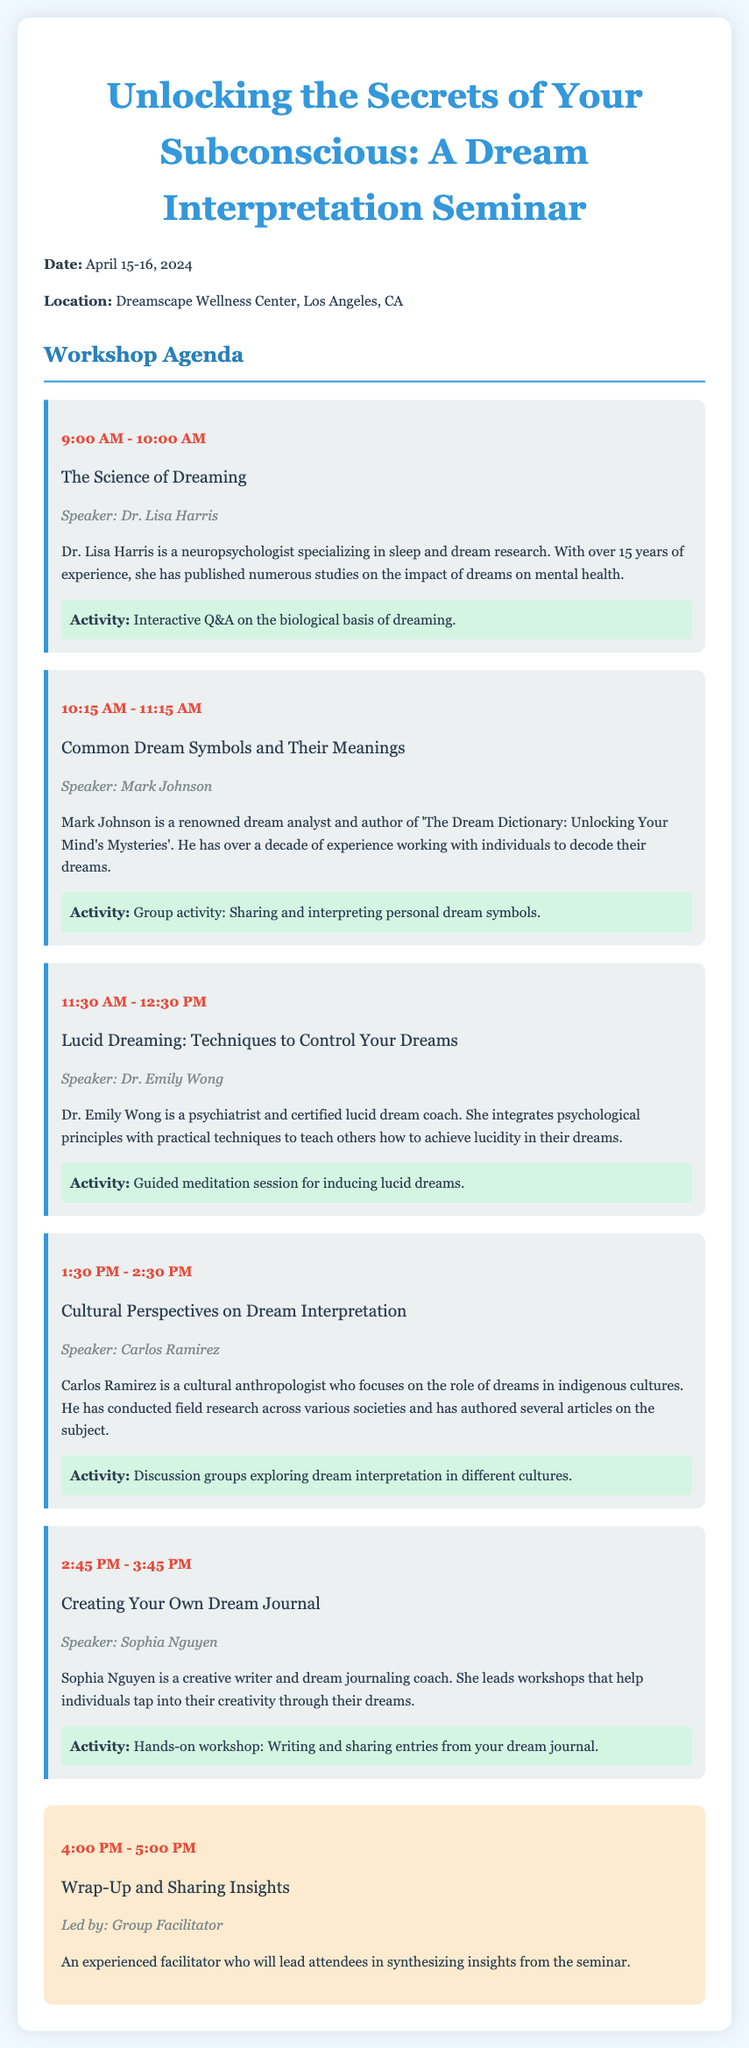what is the date of the seminar? The date of the seminar is specified at the beginning of the document.
Answer: April 15-16, 2024 what is the location of the seminar? The location of the seminar is mentioned in the introductory section of the document.
Answer: Dreamscape Wellness Center, Los Angeles, CA who is the speaker for the session on lucid dreaming? The speaker for the session on lucid dreaming can be found within the session details.
Answer: Dr. Emily Wong what is the title of the session at 1:30 PM? The title of the session at 1:30 PM is indicated in the session schedule.
Answer: Cultural Perspectives on Dream Interpretation which session includes a guided meditation? This can be found in the session details where activities are described.
Answer: Lucid Dreaming: Techniques to Control Your Dreams how many sessions are scheduled before the wrap-up? This requires a count of all the sessions listed in the workshop agenda before the wrap-up session.
Answer: 5 who conducted field research on dreams in indigenous cultures? This information is contained in the biography of the speaker for a specific session.
Answer: Carlos Ramirez what type of activity is included in the session about creating a dream journal? The activity type can be found in the details of that particular session.
Answer: Hands-on workshop which speaker has a focus on sleep and dream research? This is found in the biography of the speaker for a specific session.
Answer: Dr. Lisa Harris 